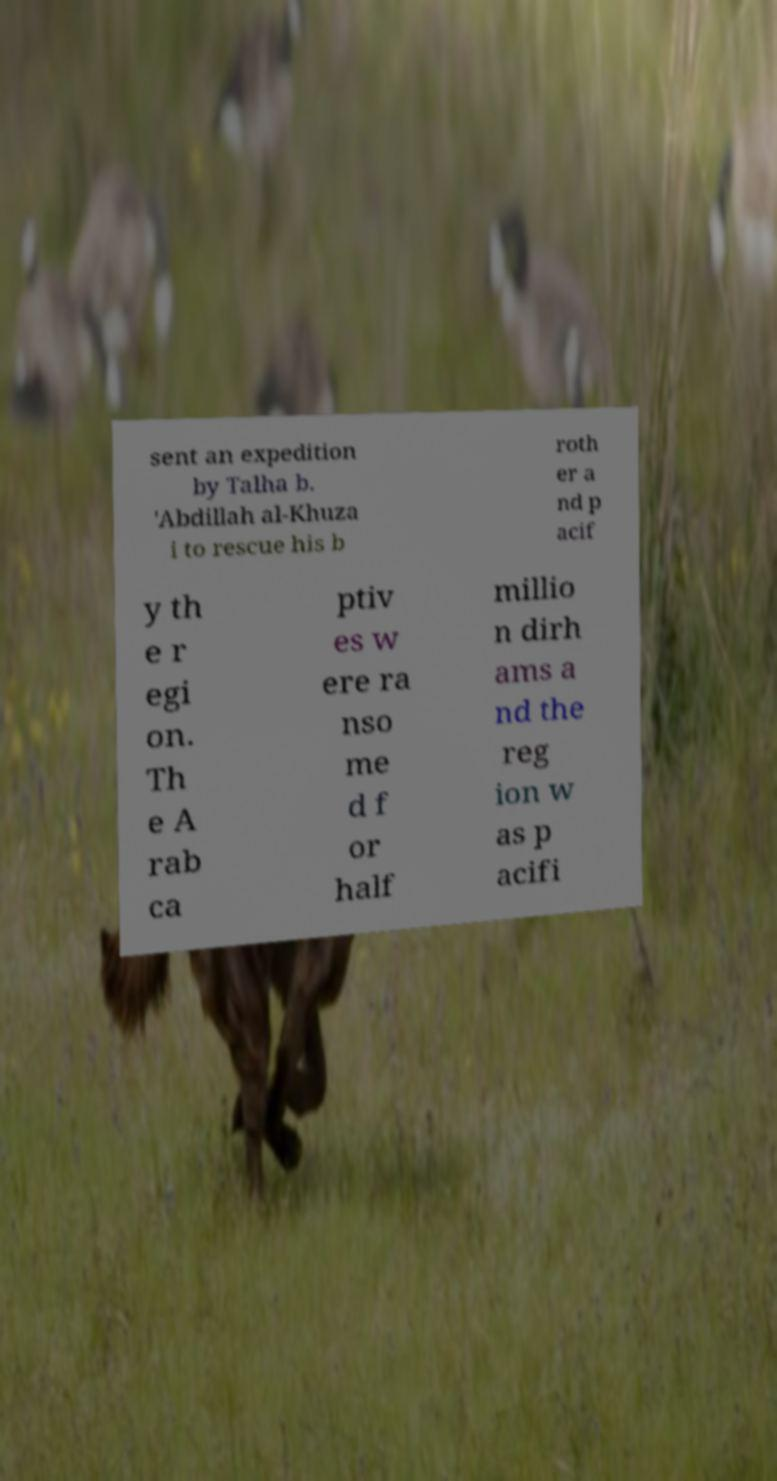I need the written content from this picture converted into text. Can you do that? sent an expedition by Talha b. 'Abdillah al-Khuza i to rescue his b roth er a nd p acif y th e r egi on. Th e A rab ca ptiv es w ere ra nso me d f or half millio n dirh ams a nd the reg ion w as p acifi 